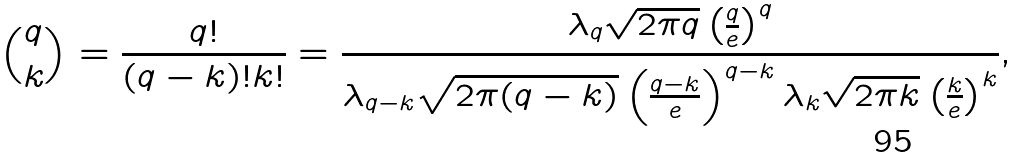Convert formula to latex. <formula><loc_0><loc_0><loc_500><loc_500>\binom { q } { k } = \frac { q ! } { ( q - k ) ! k ! } = \frac { \lambda _ { q } \sqrt { 2 \pi q } \left ( \frac { q } { e } \right ) ^ { q } } { \lambda _ { q - k } \sqrt { 2 \pi ( q - k ) } \left ( \frac { q - k } { e } \right ) ^ { q - k } \lambda _ { k } \sqrt { 2 \pi k } \left ( \frac { k } { e } \right ) ^ { k } } ,</formula> 